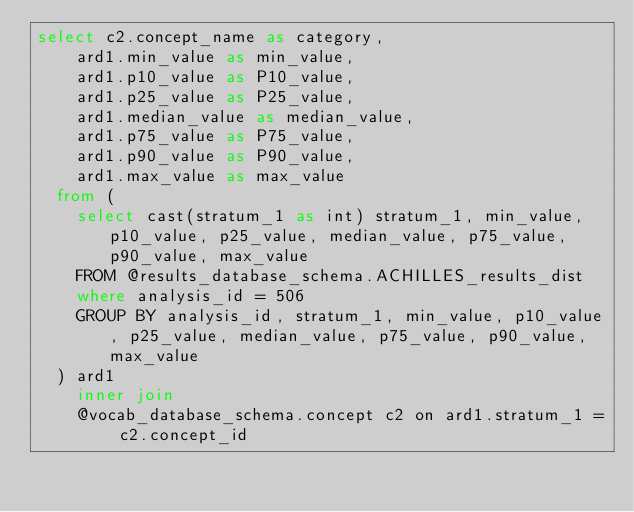<code> <loc_0><loc_0><loc_500><loc_500><_SQL_>select c2.concept_name as category,
	ard1.min_value as min_value,
	ard1.p10_value as P10_value,
	ard1.p25_value as P25_value,
	ard1.median_value as median_value,
	ard1.p75_value as P75_value,
	ard1.p90_value as P90_value,
	ard1.max_value as max_value
  from (
    select cast(stratum_1 as int) stratum_1, min_value, p10_value, p25_value, median_value, p75_value, p90_value, max_value
    FROM @results_database_schema.ACHILLES_results_dist  
    where analysis_id = 506
    GROUP BY analysis_id, stratum_1, min_value, p10_value, p25_value, median_value, p75_value, p90_value, max_value 
  ) ard1
	inner join
	@vocab_database_schema.concept c2 on ard1.stratum_1 = c2.concept_id
</code> 